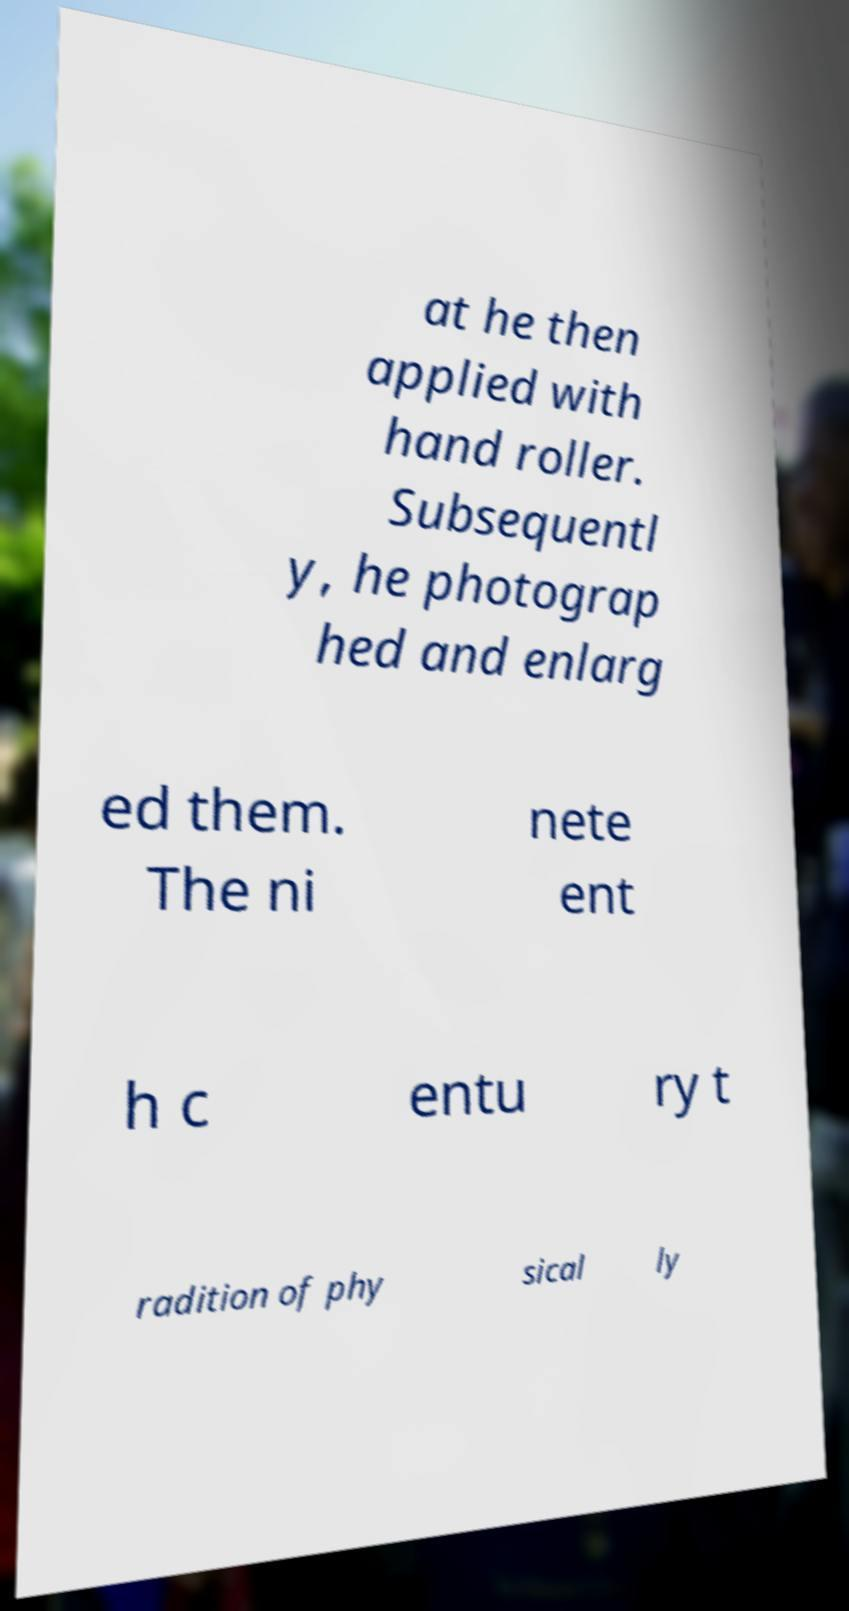Can you accurately transcribe the text from the provided image for me? at he then applied with hand roller. Subsequentl y, he photograp hed and enlarg ed them. The ni nete ent h c entu ry t radition of phy sical ly 